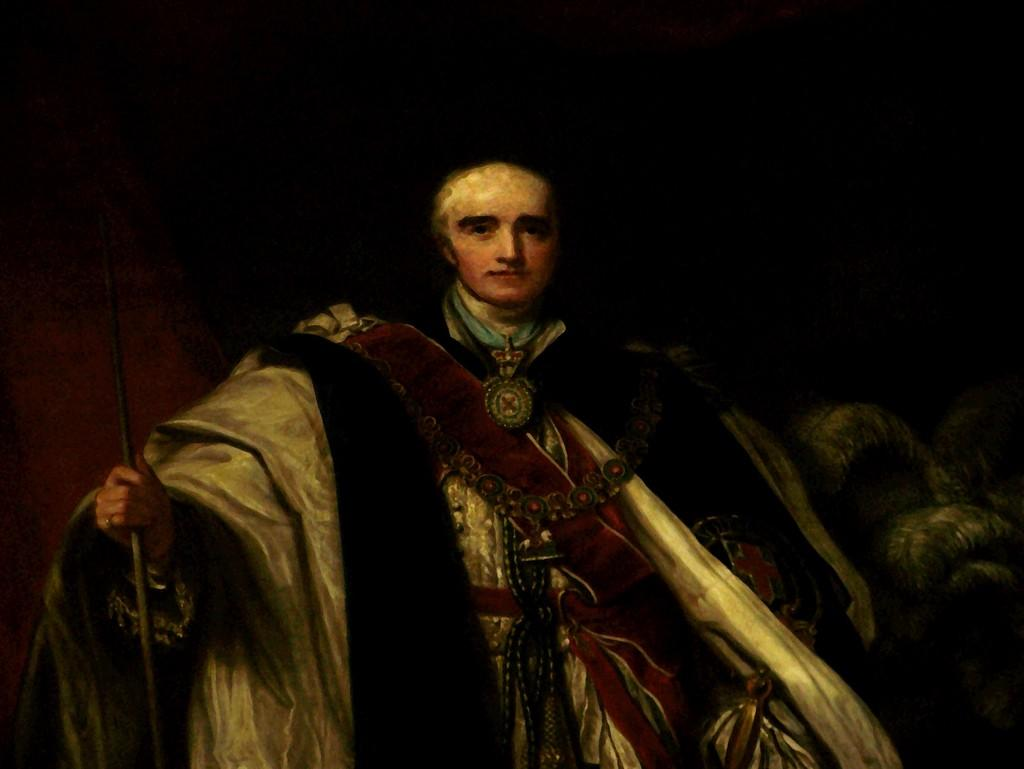What type of artwork is depicted in the image? The image is a painting. Can you describe the subject of the painting? There is a person in the painting. What is the person wearing in the painting? The person is wearing a costume. What object is the person holding in the painting? The person is holding a stick. What type of comfort can be seen in the person's smile in the painting? There is no smile present in the painting, so it is not possible to determine the type of comfort. 